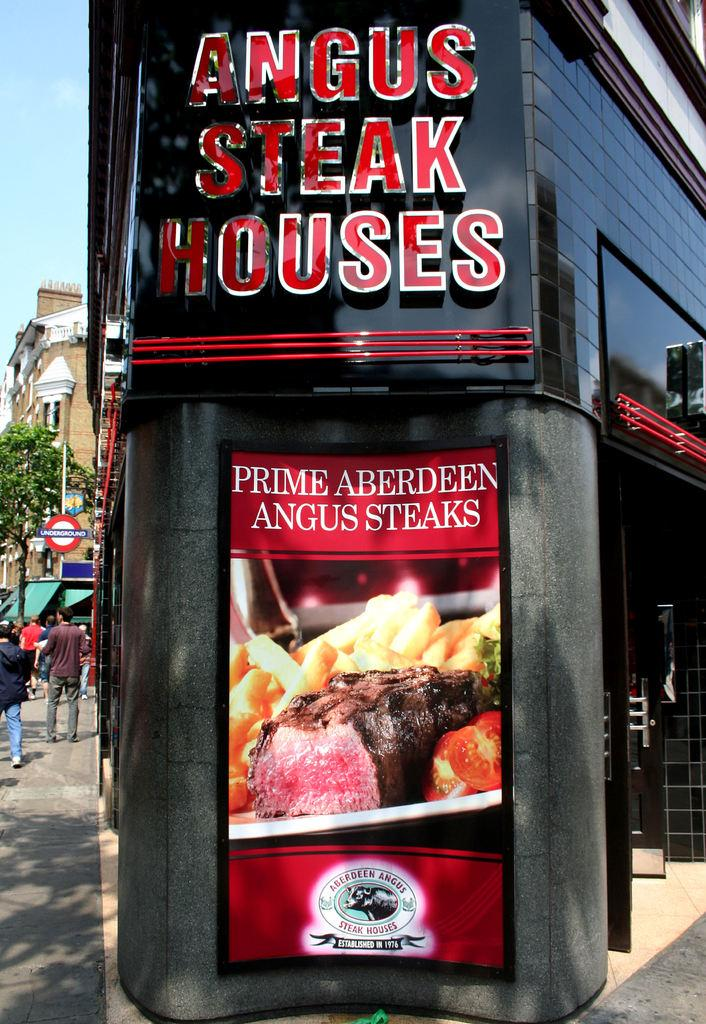Provide a one-sentence caption for the provided image. Large advertisement for a steak restaurant, Prime Aberdeen Angus steaks. 